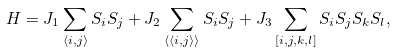Convert formula to latex. <formula><loc_0><loc_0><loc_500><loc_500>H = J _ { 1 } \sum _ { \langle i , j \rangle } S _ { i } S _ { j } + J _ { 2 } \sum _ { \langle \langle i , j \rangle \rangle } S _ { i } S _ { j } + J _ { 3 } \sum _ { [ i , j , k , l ] } S _ { i } S _ { j } S _ { k } S _ { l } ,</formula> 